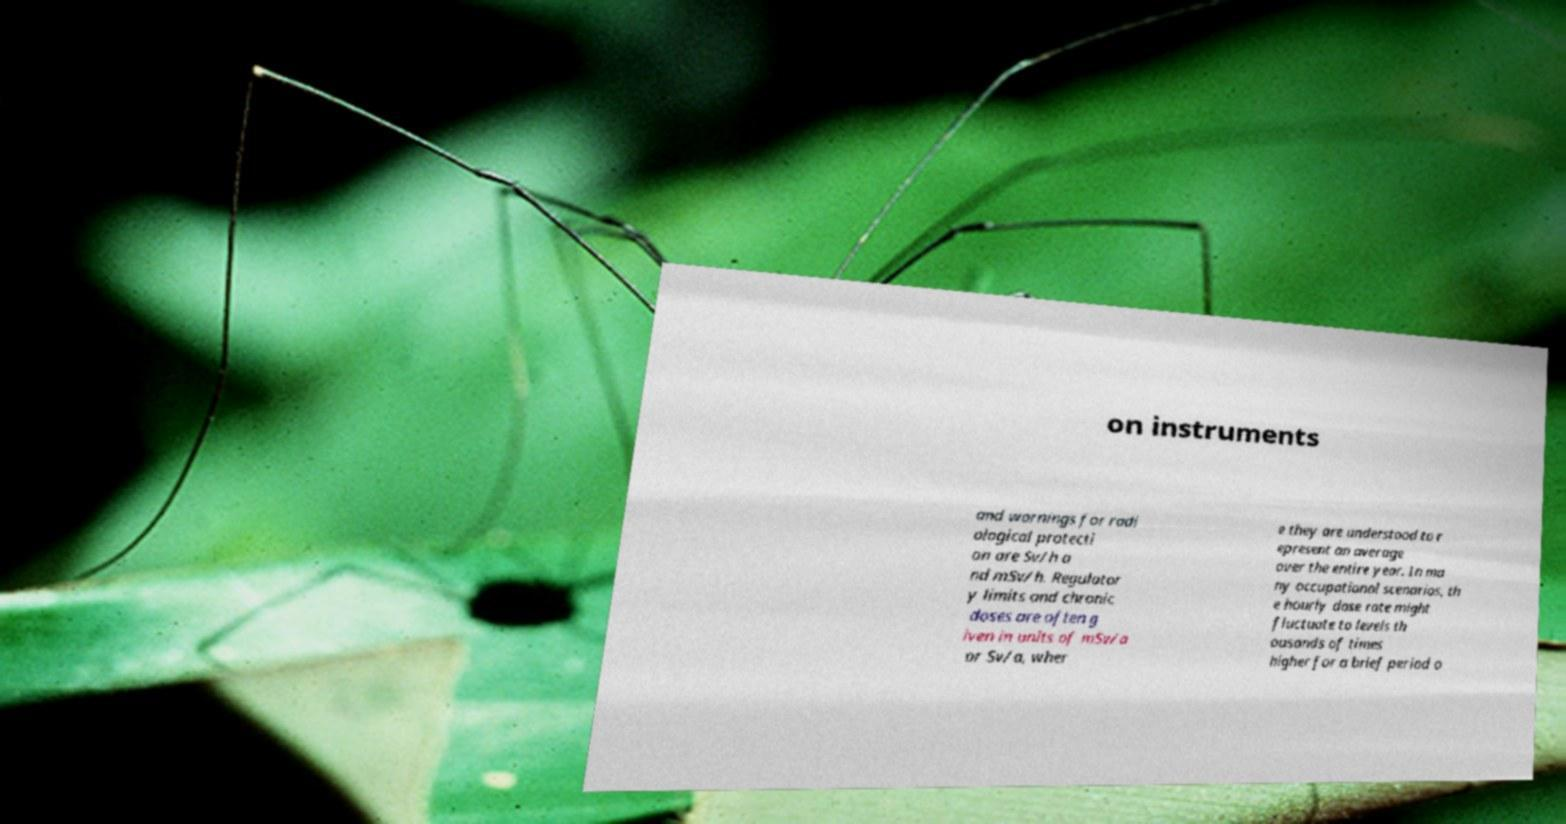Please identify and transcribe the text found in this image. on instruments and warnings for radi ological protecti on are Sv/h a nd mSv/h. Regulator y limits and chronic doses are often g iven in units of mSv/a or Sv/a, wher e they are understood to r epresent an average over the entire year. In ma ny occupational scenarios, th e hourly dose rate might fluctuate to levels th ousands of times higher for a brief period o 